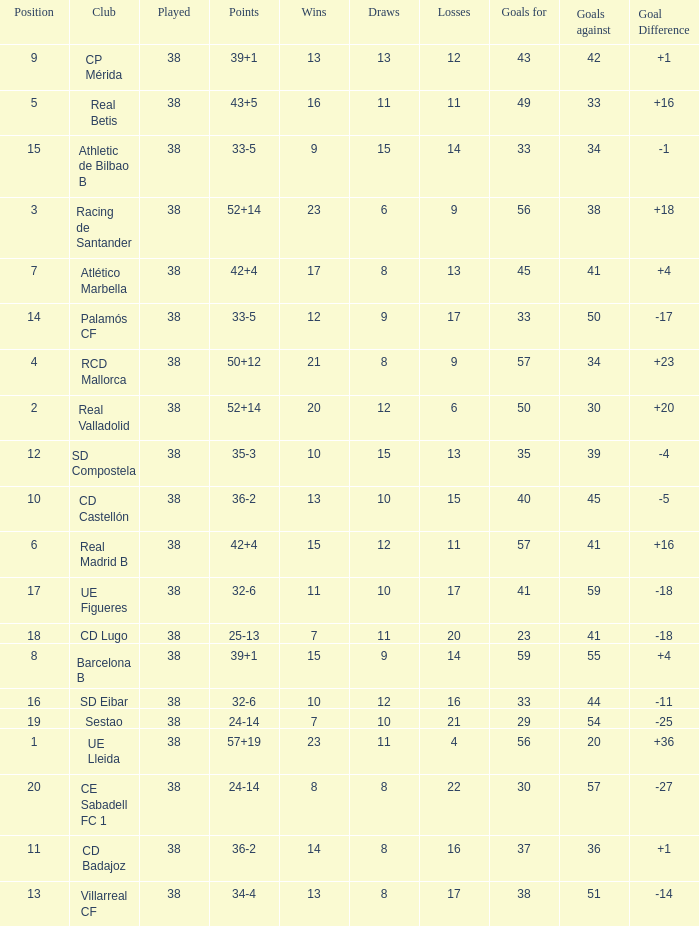What is the highest number played with a goal difference less than -27? None. 